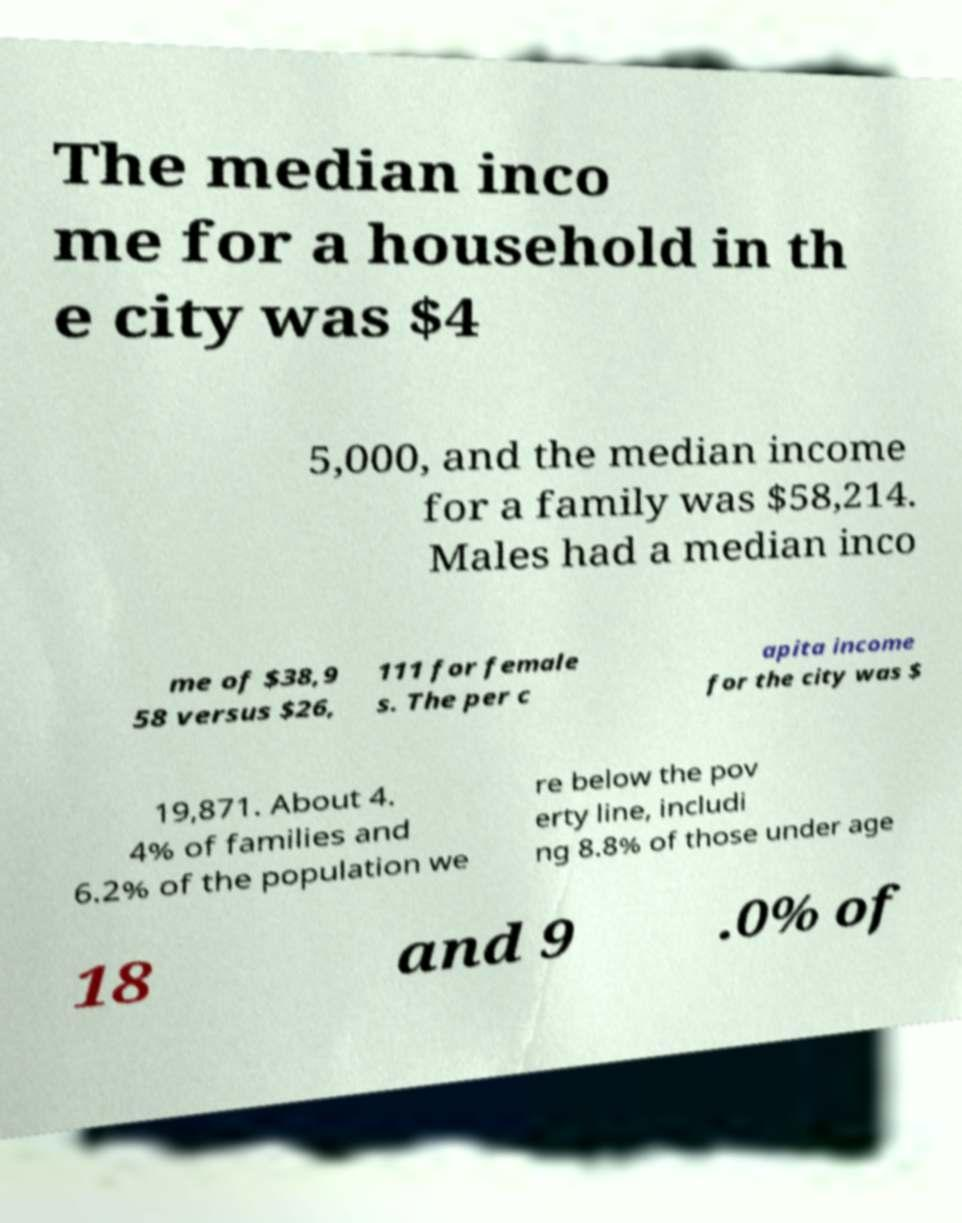For documentation purposes, I need the text within this image transcribed. Could you provide that? The median inco me for a household in th e city was $4 5,000, and the median income for a family was $58,214. Males had a median inco me of $38,9 58 versus $26, 111 for female s. The per c apita income for the city was $ 19,871. About 4. 4% of families and 6.2% of the population we re below the pov erty line, includi ng 8.8% of those under age 18 and 9 .0% of 